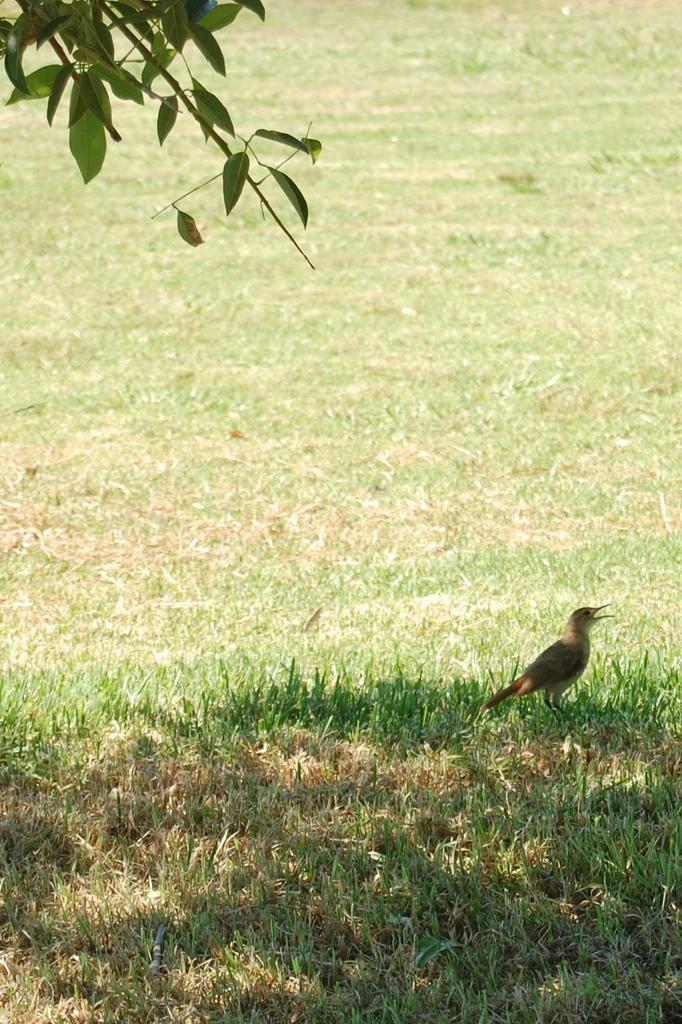In one or two sentences, can you explain what this image depicts? In this image we can see a bird. At the bottom there is grass. On the left we can see a tree. 